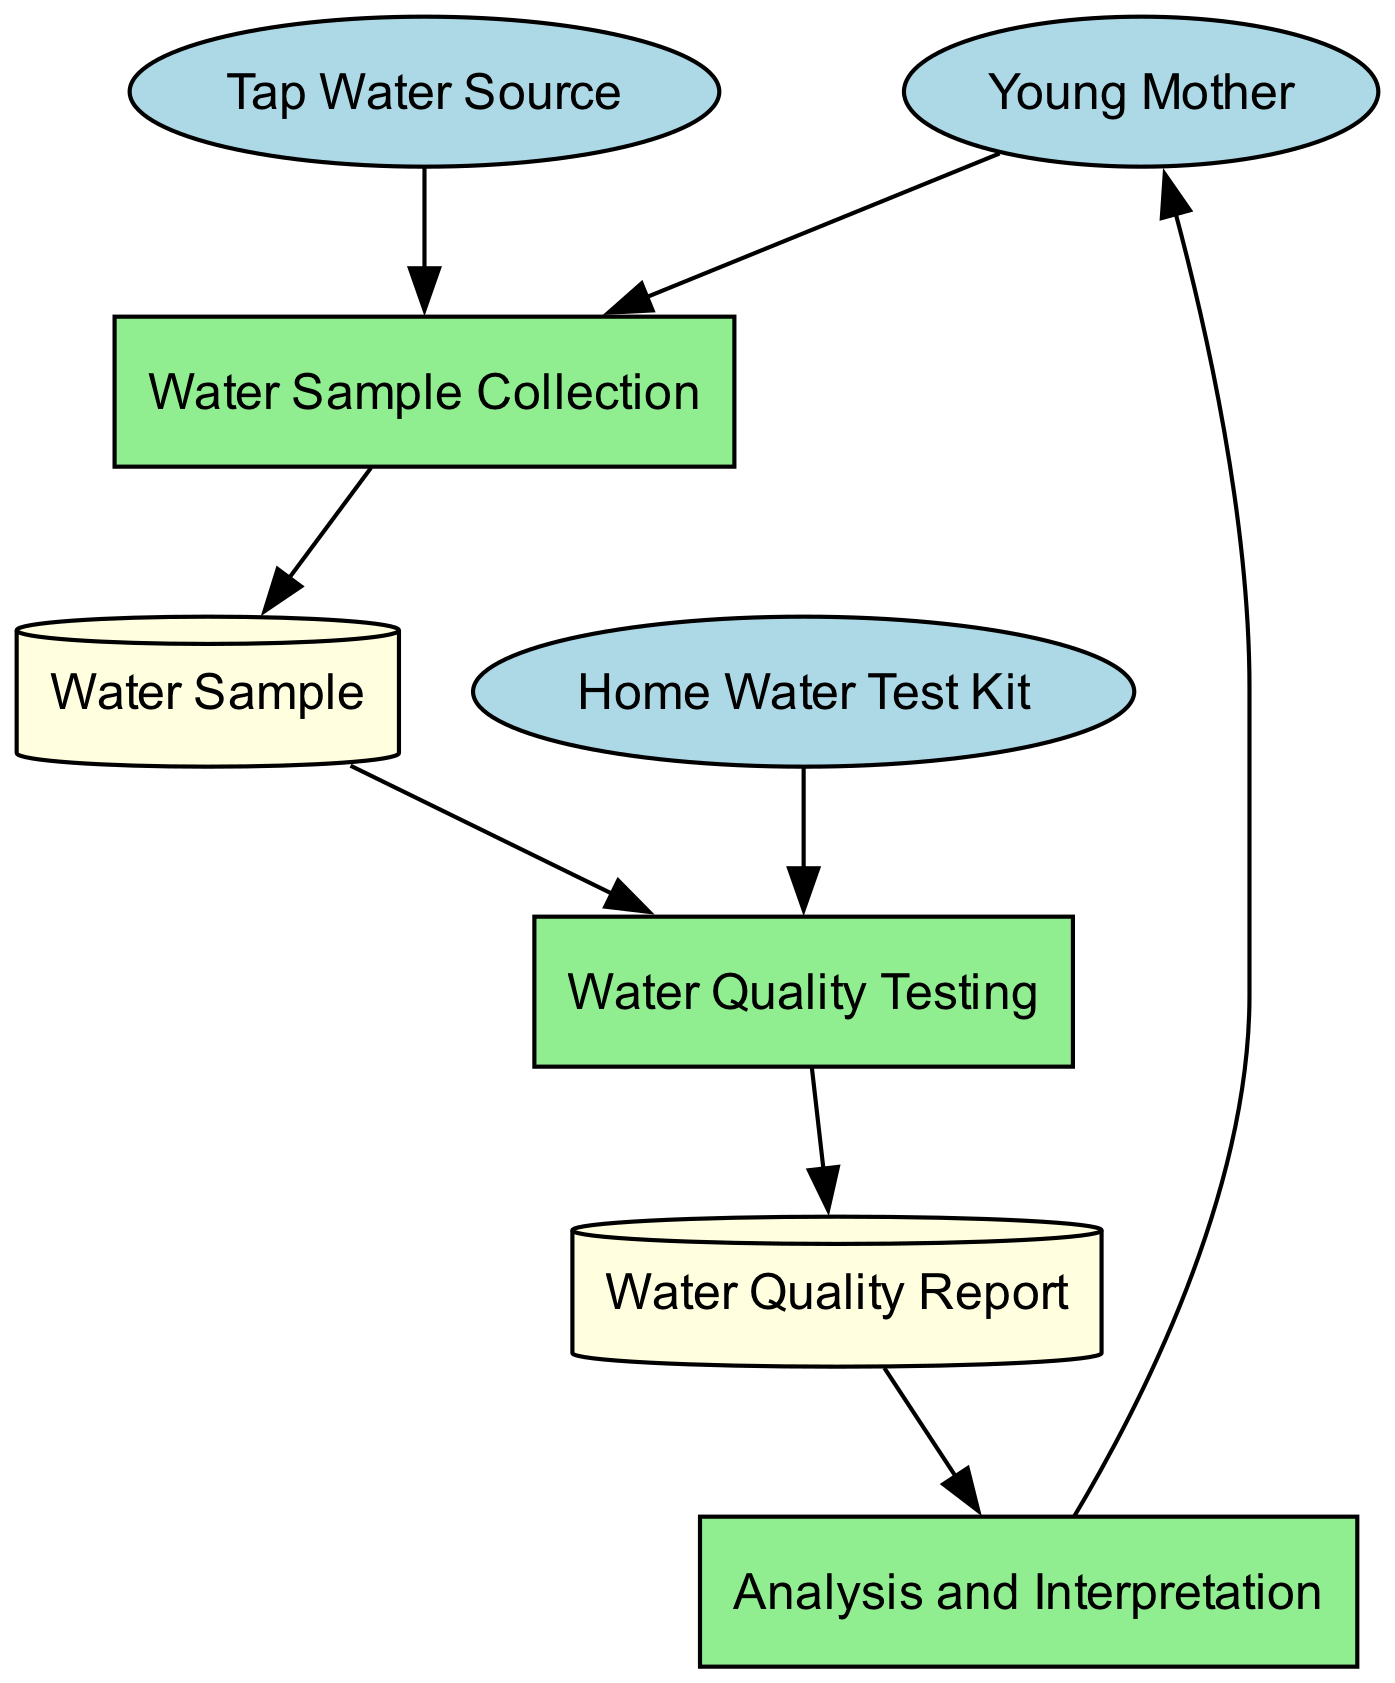What are the two external entities in the diagram? The diagram identifies two external entities: "Young Mother" and "Tap Water Source." These are the entities that interact directly with the processes in the diagram.
Answer: Young Mother, Tap Water Source How many processes are there in the diagram? There are three processes in the diagram: "Water Sample Collection," "Water Quality Testing," and "Analysis and Interpretation." This can be determined by counting the labeled rectangles representing the processes.
Answer: 3 What does the Young Mother receive at the end of the process? The final output of the process flow directed to the "Young Mother" is the "Water Quality Report," which contains the results of the water testing and analysis.
Answer: Water Quality Report Which process comes after Water Quality Testing? The process that follows "Water Quality Testing" is "Analysis and Interpretation." You can identify this by looking at the flow arrows directing from one process to the next in the diagram.
Answer: Analysis and Interpretation From where does the Water Sample originate? The "Water Sample" is collected through the process "Water Sample Collection," which takes input from "Tap Water Source." Thus, it originates from the tap water source linked to the collection process.
Answer: Tap Water Source What external entity provides the tools for testing? The "Home Water Test Kit" is the external entity responsible for providing the testing tools needed in the "Water Quality Testing" process. This is indicated by its direct link to the testing process.
Answer: Home Water Test Kit Which step must be completed first before testing the water quality? The first step that must be completed is "Water Sample Collection," as it is necessary to collect a sample before conducting any tests on it. This is represented as the starting point in the diagram flow.
Answer: Water Sample Collection What type of data store is used to hold the results of the tests? The data store that holds the results of the tests is labeled as "Water Quality Report," which is represented in the diagram as a cylinder symbol indicating it functions as a data store.
Answer: Water Quality Report Describe the relationship between Analysis and Interpretation and Young Mother. The relationship depicted in the diagram shows that the findings from "Analysis and Interpretation" are directed back to the "Young Mother," indicating that she receives the analyzed results of the water quality. This establishes a flow of information back to the external entity.
Answer: Analysis and Interpretation → Young Mother 